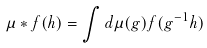<formula> <loc_0><loc_0><loc_500><loc_500>\mu \ast f ( h ) = \int d \mu ( g ) f ( g ^ { - 1 } h )</formula> 